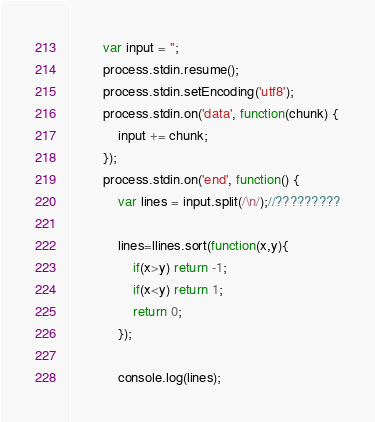Convert code to text. <code><loc_0><loc_0><loc_500><loc_500><_JavaScript_>        var input = '';
        process.stdin.resume();
        process.stdin.setEncoding('utf8');
        process.stdin.on('data', function(chunk) {
            input += chunk;
        });
        process.stdin.on('end', function() {
            var lines = input.split(/\n/);//?????????

            lines=llines.sort(function(x,y){
                if(x>y) return -1;
                if(x<y) return 1;
                return 0; 
            });

            console.log(lines);</code> 